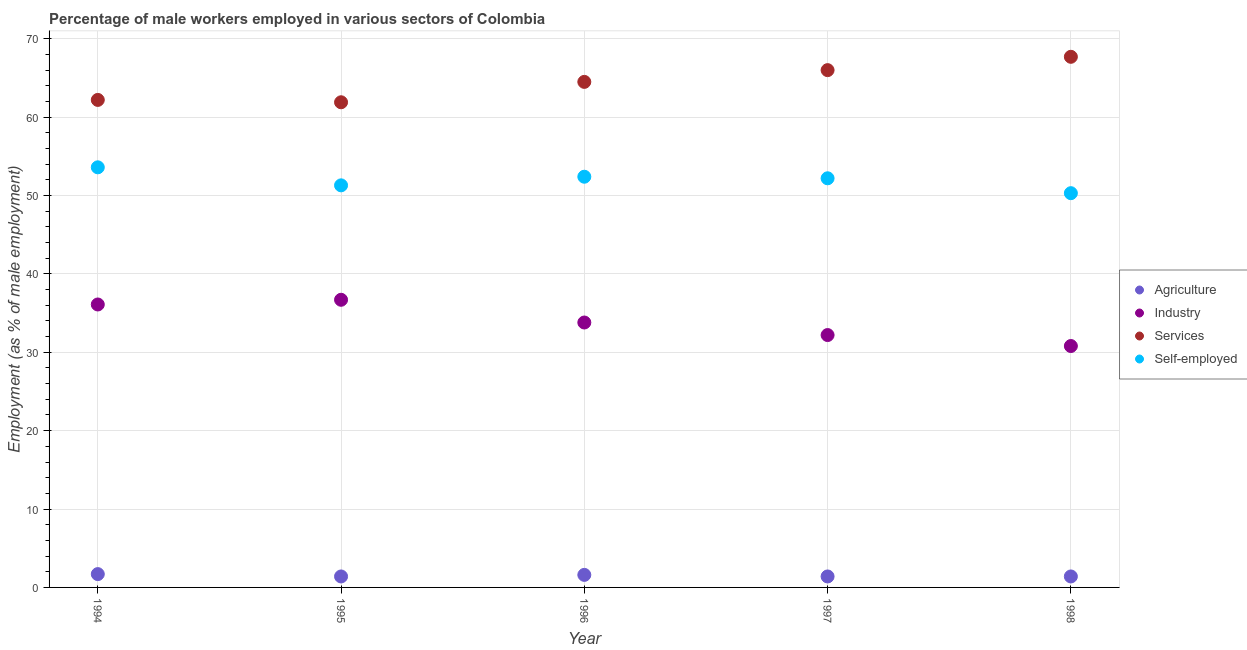Is the number of dotlines equal to the number of legend labels?
Make the answer very short. Yes. What is the percentage of self employed male workers in 1994?
Your answer should be compact. 53.6. Across all years, what is the maximum percentage of male workers in industry?
Provide a succinct answer. 36.7. Across all years, what is the minimum percentage of male workers in agriculture?
Offer a very short reply. 1.4. In which year was the percentage of male workers in agriculture maximum?
Ensure brevity in your answer.  1994. In which year was the percentage of male workers in agriculture minimum?
Your answer should be compact. 1995. What is the total percentage of male workers in industry in the graph?
Make the answer very short. 169.6. What is the difference between the percentage of male workers in services in 1995 and that in 1997?
Keep it short and to the point. -4.1. What is the difference between the percentage of male workers in industry in 1997 and the percentage of self employed male workers in 1995?
Offer a terse response. -19.1. What is the average percentage of self employed male workers per year?
Offer a very short reply. 51.96. In the year 1998, what is the difference between the percentage of male workers in industry and percentage of male workers in agriculture?
Make the answer very short. 29.4. In how many years, is the percentage of male workers in industry greater than 24 %?
Provide a succinct answer. 5. What is the ratio of the percentage of self employed male workers in 1994 to that in 1997?
Your answer should be very brief. 1.03. What is the difference between the highest and the second highest percentage of male workers in services?
Provide a short and direct response. 1.7. What is the difference between the highest and the lowest percentage of male workers in agriculture?
Your answer should be compact. 0.3. In how many years, is the percentage of self employed male workers greater than the average percentage of self employed male workers taken over all years?
Your answer should be very brief. 3. Is it the case that in every year, the sum of the percentage of male workers in services and percentage of male workers in industry is greater than the sum of percentage of male workers in agriculture and percentage of self employed male workers?
Make the answer very short. Yes. Does the percentage of male workers in agriculture monotonically increase over the years?
Offer a terse response. No. Are the values on the major ticks of Y-axis written in scientific E-notation?
Provide a succinct answer. No. Where does the legend appear in the graph?
Keep it short and to the point. Center right. What is the title of the graph?
Provide a succinct answer. Percentage of male workers employed in various sectors of Colombia. What is the label or title of the X-axis?
Provide a succinct answer. Year. What is the label or title of the Y-axis?
Your answer should be compact. Employment (as % of male employment). What is the Employment (as % of male employment) in Agriculture in 1994?
Keep it short and to the point. 1.7. What is the Employment (as % of male employment) in Industry in 1994?
Provide a succinct answer. 36.1. What is the Employment (as % of male employment) of Services in 1994?
Ensure brevity in your answer.  62.2. What is the Employment (as % of male employment) in Self-employed in 1994?
Give a very brief answer. 53.6. What is the Employment (as % of male employment) in Agriculture in 1995?
Keep it short and to the point. 1.4. What is the Employment (as % of male employment) in Industry in 1995?
Provide a short and direct response. 36.7. What is the Employment (as % of male employment) of Services in 1995?
Make the answer very short. 61.9. What is the Employment (as % of male employment) of Self-employed in 1995?
Ensure brevity in your answer.  51.3. What is the Employment (as % of male employment) of Agriculture in 1996?
Your response must be concise. 1.6. What is the Employment (as % of male employment) in Industry in 1996?
Your response must be concise. 33.8. What is the Employment (as % of male employment) of Services in 1996?
Offer a very short reply. 64.5. What is the Employment (as % of male employment) of Self-employed in 1996?
Give a very brief answer. 52.4. What is the Employment (as % of male employment) in Agriculture in 1997?
Keep it short and to the point. 1.4. What is the Employment (as % of male employment) of Industry in 1997?
Keep it short and to the point. 32.2. What is the Employment (as % of male employment) in Self-employed in 1997?
Your answer should be compact. 52.2. What is the Employment (as % of male employment) of Agriculture in 1998?
Provide a succinct answer. 1.4. What is the Employment (as % of male employment) of Industry in 1998?
Your response must be concise. 30.8. What is the Employment (as % of male employment) of Services in 1998?
Give a very brief answer. 67.7. What is the Employment (as % of male employment) of Self-employed in 1998?
Offer a terse response. 50.3. Across all years, what is the maximum Employment (as % of male employment) of Agriculture?
Provide a succinct answer. 1.7. Across all years, what is the maximum Employment (as % of male employment) of Industry?
Ensure brevity in your answer.  36.7. Across all years, what is the maximum Employment (as % of male employment) of Services?
Give a very brief answer. 67.7. Across all years, what is the maximum Employment (as % of male employment) of Self-employed?
Ensure brevity in your answer.  53.6. Across all years, what is the minimum Employment (as % of male employment) in Agriculture?
Your response must be concise. 1.4. Across all years, what is the minimum Employment (as % of male employment) in Industry?
Your answer should be compact. 30.8. Across all years, what is the minimum Employment (as % of male employment) of Services?
Make the answer very short. 61.9. Across all years, what is the minimum Employment (as % of male employment) in Self-employed?
Your response must be concise. 50.3. What is the total Employment (as % of male employment) of Agriculture in the graph?
Your answer should be compact. 7.5. What is the total Employment (as % of male employment) of Industry in the graph?
Provide a succinct answer. 169.6. What is the total Employment (as % of male employment) of Services in the graph?
Offer a very short reply. 322.3. What is the total Employment (as % of male employment) of Self-employed in the graph?
Your answer should be very brief. 259.8. What is the difference between the Employment (as % of male employment) of Services in 1994 and that in 1995?
Keep it short and to the point. 0.3. What is the difference between the Employment (as % of male employment) in Self-employed in 1994 and that in 1995?
Provide a succinct answer. 2.3. What is the difference between the Employment (as % of male employment) in Industry in 1994 and that in 1996?
Provide a succinct answer. 2.3. What is the difference between the Employment (as % of male employment) of Agriculture in 1994 and that in 1997?
Your answer should be very brief. 0.3. What is the difference between the Employment (as % of male employment) in Industry in 1994 and that in 1997?
Your answer should be very brief. 3.9. What is the difference between the Employment (as % of male employment) in Self-employed in 1994 and that in 1997?
Your answer should be compact. 1.4. What is the difference between the Employment (as % of male employment) in Agriculture in 1994 and that in 1998?
Provide a succinct answer. 0.3. What is the difference between the Employment (as % of male employment) in Industry in 1994 and that in 1998?
Make the answer very short. 5.3. What is the difference between the Employment (as % of male employment) in Self-employed in 1994 and that in 1998?
Provide a short and direct response. 3.3. What is the difference between the Employment (as % of male employment) of Services in 1995 and that in 1996?
Your response must be concise. -2.6. What is the difference between the Employment (as % of male employment) of Industry in 1995 and that in 1997?
Provide a short and direct response. 4.5. What is the difference between the Employment (as % of male employment) in Services in 1995 and that in 1997?
Ensure brevity in your answer.  -4.1. What is the difference between the Employment (as % of male employment) of Self-employed in 1995 and that in 1997?
Give a very brief answer. -0.9. What is the difference between the Employment (as % of male employment) of Self-employed in 1995 and that in 1998?
Keep it short and to the point. 1. What is the difference between the Employment (as % of male employment) of Agriculture in 1996 and that in 1997?
Provide a succinct answer. 0.2. What is the difference between the Employment (as % of male employment) of Self-employed in 1996 and that in 1997?
Offer a terse response. 0.2. What is the difference between the Employment (as % of male employment) in Industry in 1996 and that in 1998?
Keep it short and to the point. 3. What is the difference between the Employment (as % of male employment) of Services in 1996 and that in 1998?
Your answer should be compact. -3.2. What is the difference between the Employment (as % of male employment) of Industry in 1997 and that in 1998?
Offer a very short reply. 1.4. What is the difference between the Employment (as % of male employment) in Services in 1997 and that in 1998?
Provide a succinct answer. -1.7. What is the difference between the Employment (as % of male employment) in Agriculture in 1994 and the Employment (as % of male employment) in Industry in 1995?
Your response must be concise. -35. What is the difference between the Employment (as % of male employment) of Agriculture in 1994 and the Employment (as % of male employment) of Services in 1995?
Provide a succinct answer. -60.2. What is the difference between the Employment (as % of male employment) of Agriculture in 1994 and the Employment (as % of male employment) of Self-employed in 1995?
Keep it short and to the point. -49.6. What is the difference between the Employment (as % of male employment) in Industry in 1994 and the Employment (as % of male employment) in Services in 1995?
Provide a short and direct response. -25.8. What is the difference between the Employment (as % of male employment) of Industry in 1994 and the Employment (as % of male employment) of Self-employed in 1995?
Make the answer very short. -15.2. What is the difference between the Employment (as % of male employment) of Services in 1994 and the Employment (as % of male employment) of Self-employed in 1995?
Your answer should be compact. 10.9. What is the difference between the Employment (as % of male employment) of Agriculture in 1994 and the Employment (as % of male employment) of Industry in 1996?
Offer a terse response. -32.1. What is the difference between the Employment (as % of male employment) of Agriculture in 1994 and the Employment (as % of male employment) of Services in 1996?
Make the answer very short. -62.8. What is the difference between the Employment (as % of male employment) in Agriculture in 1994 and the Employment (as % of male employment) in Self-employed in 1996?
Make the answer very short. -50.7. What is the difference between the Employment (as % of male employment) in Industry in 1994 and the Employment (as % of male employment) in Services in 1996?
Provide a succinct answer. -28.4. What is the difference between the Employment (as % of male employment) of Industry in 1994 and the Employment (as % of male employment) of Self-employed in 1996?
Keep it short and to the point. -16.3. What is the difference between the Employment (as % of male employment) of Services in 1994 and the Employment (as % of male employment) of Self-employed in 1996?
Provide a short and direct response. 9.8. What is the difference between the Employment (as % of male employment) in Agriculture in 1994 and the Employment (as % of male employment) in Industry in 1997?
Keep it short and to the point. -30.5. What is the difference between the Employment (as % of male employment) of Agriculture in 1994 and the Employment (as % of male employment) of Services in 1997?
Offer a very short reply. -64.3. What is the difference between the Employment (as % of male employment) of Agriculture in 1994 and the Employment (as % of male employment) of Self-employed in 1997?
Offer a very short reply. -50.5. What is the difference between the Employment (as % of male employment) of Industry in 1994 and the Employment (as % of male employment) of Services in 1997?
Your response must be concise. -29.9. What is the difference between the Employment (as % of male employment) of Industry in 1994 and the Employment (as % of male employment) of Self-employed in 1997?
Provide a succinct answer. -16.1. What is the difference between the Employment (as % of male employment) of Agriculture in 1994 and the Employment (as % of male employment) of Industry in 1998?
Offer a terse response. -29.1. What is the difference between the Employment (as % of male employment) in Agriculture in 1994 and the Employment (as % of male employment) in Services in 1998?
Offer a very short reply. -66. What is the difference between the Employment (as % of male employment) in Agriculture in 1994 and the Employment (as % of male employment) in Self-employed in 1998?
Provide a succinct answer. -48.6. What is the difference between the Employment (as % of male employment) in Industry in 1994 and the Employment (as % of male employment) in Services in 1998?
Make the answer very short. -31.6. What is the difference between the Employment (as % of male employment) in Industry in 1994 and the Employment (as % of male employment) in Self-employed in 1998?
Ensure brevity in your answer.  -14.2. What is the difference between the Employment (as % of male employment) of Agriculture in 1995 and the Employment (as % of male employment) of Industry in 1996?
Your answer should be very brief. -32.4. What is the difference between the Employment (as % of male employment) of Agriculture in 1995 and the Employment (as % of male employment) of Services in 1996?
Provide a short and direct response. -63.1. What is the difference between the Employment (as % of male employment) in Agriculture in 1995 and the Employment (as % of male employment) in Self-employed in 1996?
Provide a succinct answer. -51. What is the difference between the Employment (as % of male employment) in Industry in 1995 and the Employment (as % of male employment) in Services in 1996?
Your answer should be very brief. -27.8. What is the difference between the Employment (as % of male employment) of Industry in 1995 and the Employment (as % of male employment) of Self-employed in 1996?
Make the answer very short. -15.7. What is the difference between the Employment (as % of male employment) in Agriculture in 1995 and the Employment (as % of male employment) in Industry in 1997?
Make the answer very short. -30.8. What is the difference between the Employment (as % of male employment) in Agriculture in 1995 and the Employment (as % of male employment) in Services in 1997?
Provide a succinct answer. -64.6. What is the difference between the Employment (as % of male employment) of Agriculture in 1995 and the Employment (as % of male employment) of Self-employed in 1997?
Ensure brevity in your answer.  -50.8. What is the difference between the Employment (as % of male employment) in Industry in 1995 and the Employment (as % of male employment) in Services in 1997?
Offer a terse response. -29.3. What is the difference between the Employment (as % of male employment) of Industry in 1995 and the Employment (as % of male employment) of Self-employed in 1997?
Your answer should be compact. -15.5. What is the difference between the Employment (as % of male employment) in Agriculture in 1995 and the Employment (as % of male employment) in Industry in 1998?
Offer a terse response. -29.4. What is the difference between the Employment (as % of male employment) in Agriculture in 1995 and the Employment (as % of male employment) in Services in 1998?
Provide a short and direct response. -66.3. What is the difference between the Employment (as % of male employment) in Agriculture in 1995 and the Employment (as % of male employment) in Self-employed in 1998?
Your answer should be compact. -48.9. What is the difference between the Employment (as % of male employment) in Industry in 1995 and the Employment (as % of male employment) in Services in 1998?
Ensure brevity in your answer.  -31. What is the difference between the Employment (as % of male employment) of Industry in 1995 and the Employment (as % of male employment) of Self-employed in 1998?
Give a very brief answer. -13.6. What is the difference between the Employment (as % of male employment) of Services in 1995 and the Employment (as % of male employment) of Self-employed in 1998?
Offer a very short reply. 11.6. What is the difference between the Employment (as % of male employment) of Agriculture in 1996 and the Employment (as % of male employment) of Industry in 1997?
Provide a short and direct response. -30.6. What is the difference between the Employment (as % of male employment) of Agriculture in 1996 and the Employment (as % of male employment) of Services in 1997?
Your answer should be very brief. -64.4. What is the difference between the Employment (as % of male employment) of Agriculture in 1996 and the Employment (as % of male employment) of Self-employed in 1997?
Provide a succinct answer. -50.6. What is the difference between the Employment (as % of male employment) of Industry in 1996 and the Employment (as % of male employment) of Services in 1997?
Ensure brevity in your answer.  -32.2. What is the difference between the Employment (as % of male employment) of Industry in 1996 and the Employment (as % of male employment) of Self-employed in 1997?
Ensure brevity in your answer.  -18.4. What is the difference between the Employment (as % of male employment) of Services in 1996 and the Employment (as % of male employment) of Self-employed in 1997?
Provide a short and direct response. 12.3. What is the difference between the Employment (as % of male employment) in Agriculture in 1996 and the Employment (as % of male employment) in Industry in 1998?
Ensure brevity in your answer.  -29.2. What is the difference between the Employment (as % of male employment) of Agriculture in 1996 and the Employment (as % of male employment) of Services in 1998?
Keep it short and to the point. -66.1. What is the difference between the Employment (as % of male employment) of Agriculture in 1996 and the Employment (as % of male employment) of Self-employed in 1998?
Offer a terse response. -48.7. What is the difference between the Employment (as % of male employment) in Industry in 1996 and the Employment (as % of male employment) in Services in 1998?
Offer a very short reply. -33.9. What is the difference between the Employment (as % of male employment) of Industry in 1996 and the Employment (as % of male employment) of Self-employed in 1998?
Your response must be concise. -16.5. What is the difference between the Employment (as % of male employment) of Agriculture in 1997 and the Employment (as % of male employment) of Industry in 1998?
Your answer should be very brief. -29.4. What is the difference between the Employment (as % of male employment) in Agriculture in 1997 and the Employment (as % of male employment) in Services in 1998?
Give a very brief answer. -66.3. What is the difference between the Employment (as % of male employment) of Agriculture in 1997 and the Employment (as % of male employment) of Self-employed in 1998?
Your answer should be very brief. -48.9. What is the difference between the Employment (as % of male employment) of Industry in 1997 and the Employment (as % of male employment) of Services in 1998?
Ensure brevity in your answer.  -35.5. What is the difference between the Employment (as % of male employment) of Industry in 1997 and the Employment (as % of male employment) of Self-employed in 1998?
Make the answer very short. -18.1. What is the difference between the Employment (as % of male employment) of Services in 1997 and the Employment (as % of male employment) of Self-employed in 1998?
Make the answer very short. 15.7. What is the average Employment (as % of male employment) of Industry per year?
Offer a terse response. 33.92. What is the average Employment (as % of male employment) in Services per year?
Provide a succinct answer. 64.46. What is the average Employment (as % of male employment) in Self-employed per year?
Keep it short and to the point. 51.96. In the year 1994, what is the difference between the Employment (as % of male employment) in Agriculture and Employment (as % of male employment) in Industry?
Your response must be concise. -34.4. In the year 1994, what is the difference between the Employment (as % of male employment) of Agriculture and Employment (as % of male employment) of Services?
Make the answer very short. -60.5. In the year 1994, what is the difference between the Employment (as % of male employment) in Agriculture and Employment (as % of male employment) in Self-employed?
Give a very brief answer. -51.9. In the year 1994, what is the difference between the Employment (as % of male employment) of Industry and Employment (as % of male employment) of Services?
Offer a very short reply. -26.1. In the year 1994, what is the difference between the Employment (as % of male employment) in Industry and Employment (as % of male employment) in Self-employed?
Provide a succinct answer. -17.5. In the year 1995, what is the difference between the Employment (as % of male employment) of Agriculture and Employment (as % of male employment) of Industry?
Make the answer very short. -35.3. In the year 1995, what is the difference between the Employment (as % of male employment) in Agriculture and Employment (as % of male employment) in Services?
Make the answer very short. -60.5. In the year 1995, what is the difference between the Employment (as % of male employment) of Agriculture and Employment (as % of male employment) of Self-employed?
Provide a succinct answer. -49.9. In the year 1995, what is the difference between the Employment (as % of male employment) of Industry and Employment (as % of male employment) of Services?
Offer a very short reply. -25.2. In the year 1995, what is the difference between the Employment (as % of male employment) in Industry and Employment (as % of male employment) in Self-employed?
Your answer should be very brief. -14.6. In the year 1996, what is the difference between the Employment (as % of male employment) of Agriculture and Employment (as % of male employment) of Industry?
Make the answer very short. -32.2. In the year 1996, what is the difference between the Employment (as % of male employment) in Agriculture and Employment (as % of male employment) in Services?
Make the answer very short. -62.9. In the year 1996, what is the difference between the Employment (as % of male employment) of Agriculture and Employment (as % of male employment) of Self-employed?
Make the answer very short. -50.8. In the year 1996, what is the difference between the Employment (as % of male employment) of Industry and Employment (as % of male employment) of Services?
Your response must be concise. -30.7. In the year 1996, what is the difference between the Employment (as % of male employment) of Industry and Employment (as % of male employment) of Self-employed?
Offer a terse response. -18.6. In the year 1996, what is the difference between the Employment (as % of male employment) of Services and Employment (as % of male employment) of Self-employed?
Offer a terse response. 12.1. In the year 1997, what is the difference between the Employment (as % of male employment) in Agriculture and Employment (as % of male employment) in Industry?
Keep it short and to the point. -30.8. In the year 1997, what is the difference between the Employment (as % of male employment) in Agriculture and Employment (as % of male employment) in Services?
Make the answer very short. -64.6. In the year 1997, what is the difference between the Employment (as % of male employment) in Agriculture and Employment (as % of male employment) in Self-employed?
Make the answer very short. -50.8. In the year 1997, what is the difference between the Employment (as % of male employment) of Industry and Employment (as % of male employment) of Services?
Your answer should be compact. -33.8. In the year 1997, what is the difference between the Employment (as % of male employment) in Services and Employment (as % of male employment) in Self-employed?
Your response must be concise. 13.8. In the year 1998, what is the difference between the Employment (as % of male employment) of Agriculture and Employment (as % of male employment) of Industry?
Provide a short and direct response. -29.4. In the year 1998, what is the difference between the Employment (as % of male employment) in Agriculture and Employment (as % of male employment) in Services?
Provide a short and direct response. -66.3. In the year 1998, what is the difference between the Employment (as % of male employment) in Agriculture and Employment (as % of male employment) in Self-employed?
Your answer should be very brief. -48.9. In the year 1998, what is the difference between the Employment (as % of male employment) of Industry and Employment (as % of male employment) of Services?
Offer a very short reply. -36.9. In the year 1998, what is the difference between the Employment (as % of male employment) in Industry and Employment (as % of male employment) in Self-employed?
Offer a terse response. -19.5. In the year 1998, what is the difference between the Employment (as % of male employment) in Services and Employment (as % of male employment) in Self-employed?
Give a very brief answer. 17.4. What is the ratio of the Employment (as % of male employment) of Agriculture in 1994 to that in 1995?
Your answer should be very brief. 1.21. What is the ratio of the Employment (as % of male employment) in Industry in 1994 to that in 1995?
Your response must be concise. 0.98. What is the ratio of the Employment (as % of male employment) of Self-employed in 1994 to that in 1995?
Offer a terse response. 1.04. What is the ratio of the Employment (as % of male employment) in Agriculture in 1994 to that in 1996?
Your response must be concise. 1.06. What is the ratio of the Employment (as % of male employment) of Industry in 1994 to that in 1996?
Give a very brief answer. 1.07. What is the ratio of the Employment (as % of male employment) in Services in 1994 to that in 1996?
Ensure brevity in your answer.  0.96. What is the ratio of the Employment (as % of male employment) in Self-employed in 1994 to that in 1996?
Ensure brevity in your answer.  1.02. What is the ratio of the Employment (as % of male employment) of Agriculture in 1994 to that in 1997?
Provide a succinct answer. 1.21. What is the ratio of the Employment (as % of male employment) of Industry in 1994 to that in 1997?
Offer a very short reply. 1.12. What is the ratio of the Employment (as % of male employment) of Services in 1994 to that in 1997?
Offer a very short reply. 0.94. What is the ratio of the Employment (as % of male employment) of Self-employed in 1994 to that in 1997?
Offer a terse response. 1.03. What is the ratio of the Employment (as % of male employment) of Agriculture in 1994 to that in 1998?
Keep it short and to the point. 1.21. What is the ratio of the Employment (as % of male employment) of Industry in 1994 to that in 1998?
Provide a succinct answer. 1.17. What is the ratio of the Employment (as % of male employment) in Services in 1994 to that in 1998?
Offer a terse response. 0.92. What is the ratio of the Employment (as % of male employment) in Self-employed in 1994 to that in 1998?
Offer a very short reply. 1.07. What is the ratio of the Employment (as % of male employment) of Agriculture in 1995 to that in 1996?
Ensure brevity in your answer.  0.88. What is the ratio of the Employment (as % of male employment) in Industry in 1995 to that in 1996?
Provide a short and direct response. 1.09. What is the ratio of the Employment (as % of male employment) in Services in 1995 to that in 1996?
Offer a very short reply. 0.96. What is the ratio of the Employment (as % of male employment) of Self-employed in 1995 to that in 1996?
Offer a very short reply. 0.98. What is the ratio of the Employment (as % of male employment) of Agriculture in 1995 to that in 1997?
Provide a succinct answer. 1. What is the ratio of the Employment (as % of male employment) in Industry in 1995 to that in 1997?
Your answer should be compact. 1.14. What is the ratio of the Employment (as % of male employment) of Services in 1995 to that in 1997?
Your response must be concise. 0.94. What is the ratio of the Employment (as % of male employment) of Self-employed in 1995 to that in 1997?
Provide a short and direct response. 0.98. What is the ratio of the Employment (as % of male employment) of Agriculture in 1995 to that in 1998?
Your response must be concise. 1. What is the ratio of the Employment (as % of male employment) of Industry in 1995 to that in 1998?
Keep it short and to the point. 1.19. What is the ratio of the Employment (as % of male employment) of Services in 1995 to that in 1998?
Provide a succinct answer. 0.91. What is the ratio of the Employment (as % of male employment) in Self-employed in 1995 to that in 1998?
Offer a very short reply. 1.02. What is the ratio of the Employment (as % of male employment) of Agriculture in 1996 to that in 1997?
Provide a succinct answer. 1.14. What is the ratio of the Employment (as % of male employment) in Industry in 1996 to that in 1997?
Provide a short and direct response. 1.05. What is the ratio of the Employment (as % of male employment) in Services in 1996 to that in 1997?
Your answer should be compact. 0.98. What is the ratio of the Employment (as % of male employment) in Self-employed in 1996 to that in 1997?
Offer a terse response. 1. What is the ratio of the Employment (as % of male employment) of Agriculture in 1996 to that in 1998?
Provide a succinct answer. 1.14. What is the ratio of the Employment (as % of male employment) of Industry in 1996 to that in 1998?
Provide a succinct answer. 1.1. What is the ratio of the Employment (as % of male employment) in Services in 1996 to that in 1998?
Ensure brevity in your answer.  0.95. What is the ratio of the Employment (as % of male employment) in Self-employed in 1996 to that in 1998?
Offer a terse response. 1.04. What is the ratio of the Employment (as % of male employment) in Agriculture in 1997 to that in 1998?
Offer a very short reply. 1. What is the ratio of the Employment (as % of male employment) of Industry in 1997 to that in 1998?
Offer a terse response. 1.05. What is the ratio of the Employment (as % of male employment) of Services in 1997 to that in 1998?
Your response must be concise. 0.97. What is the ratio of the Employment (as % of male employment) of Self-employed in 1997 to that in 1998?
Make the answer very short. 1.04. What is the difference between the highest and the second highest Employment (as % of male employment) in Agriculture?
Your answer should be very brief. 0.1. What is the difference between the highest and the second highest Employment (as % of male employment) in Industry?
Give a very brief answer. 0.6. What is the difference between the highest and the second highest Employment (as % of male employment) of Services?
Keep it short and to the point. 1.7. What is the difference between the highest and the second highest Employment (as % of male employment) in Self-employed?
Ensure brevity in your answer.  1.2. What is the difference between the highest and the lowest Employment (as % of male employment) of Services?
Provide a short and direct response. 5.8. 